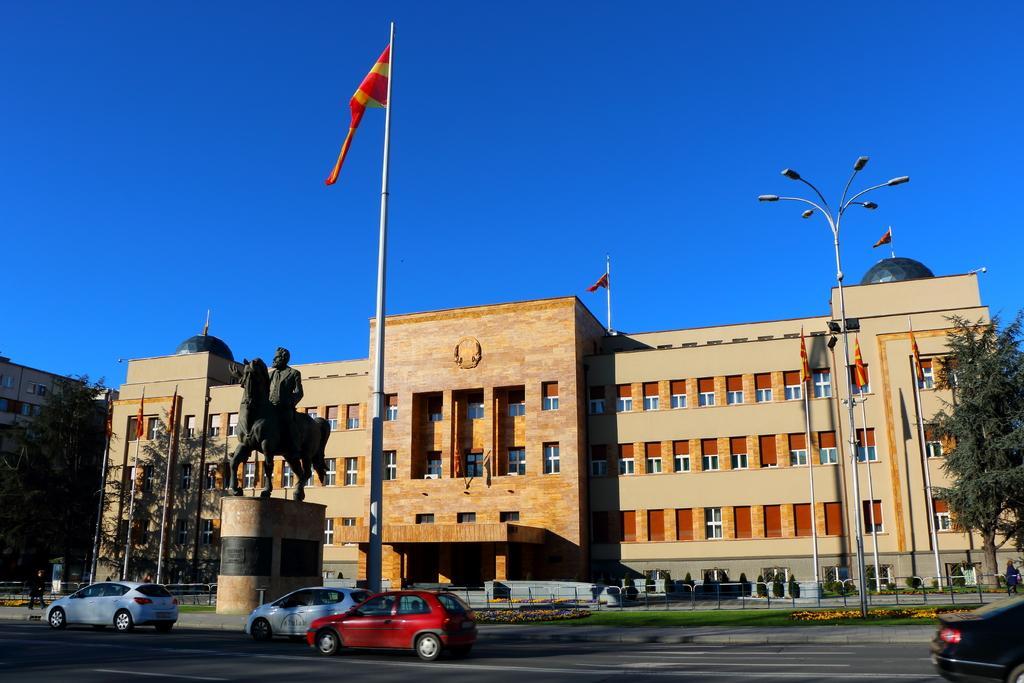How would you summarize this image in a sentence or two? This picture shows buildings and we see few flagpoles and we see trees and a statue of a man on the horse and we see cars moving on the road and walking on the sidewalk and we see pole lights and a blue sky. 